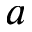Convert formula to latex. <formula><loc_0><loc_0><loc_500><loc_500>a</formula> 